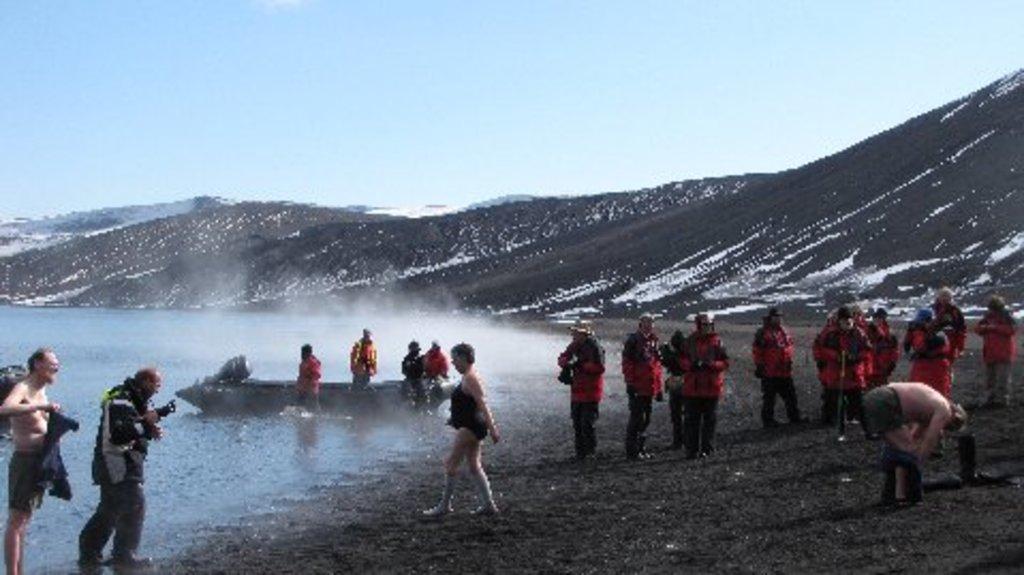Please provide a concise description of this image. In this image I can see there are persons standing on the ground and holding an object. And there is a boat on a water. And there are mountains and a snow. And at the top there is a sky. 